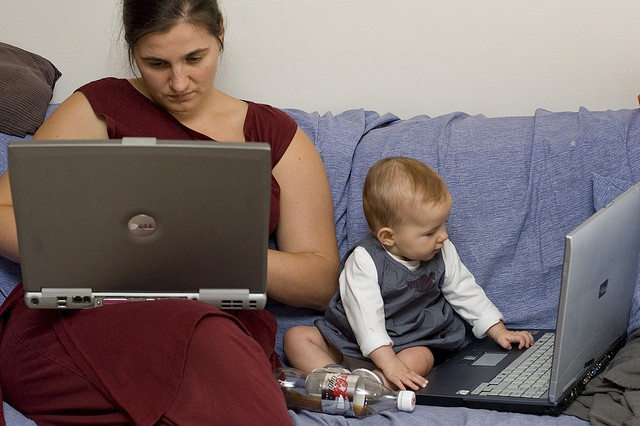Describe the objects in this image and their specific colors. I can see people in darkgray, maroon, black, and gray tones, laptop in darkgray, black, and gray tones, couch in darkgray and gray tones, people in darkgray, gray, black, and lightgray tones, and laptop in darkgray, gray, and black tones in this image. 